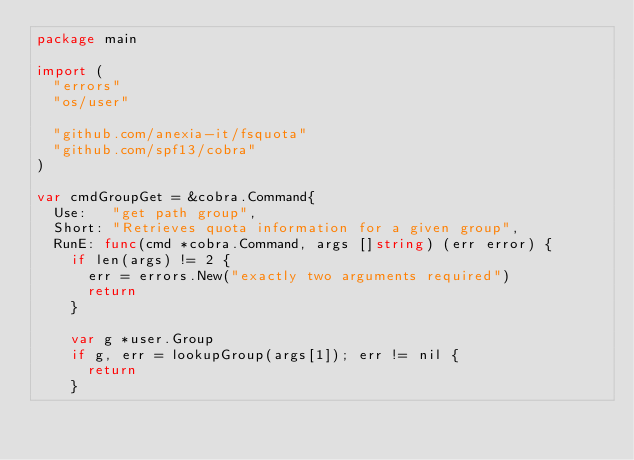Convert code to text. <code><loc_0><loc_0><loc_500><loc_500><_Go_>package main

import (
	"errors"
	"os/user"

	"github.com/anexia-it/fsquota"
	"github.com/spf13/cobra"
)

var cmdGroupGet = &cobra.Command{
	Use:   "get path group",
	Short: "Retrieves quota information for a given group",
	RunE: func(cmd *cobra.Command, args []string) (err error) {
		if len(args) != 2 {
			err = errors.New("exactly two arguments required")
			return
		}

		var g *user.Group
		if g, err = lookupGroup(args[1]); err != nil {
			return
		}
</code> 